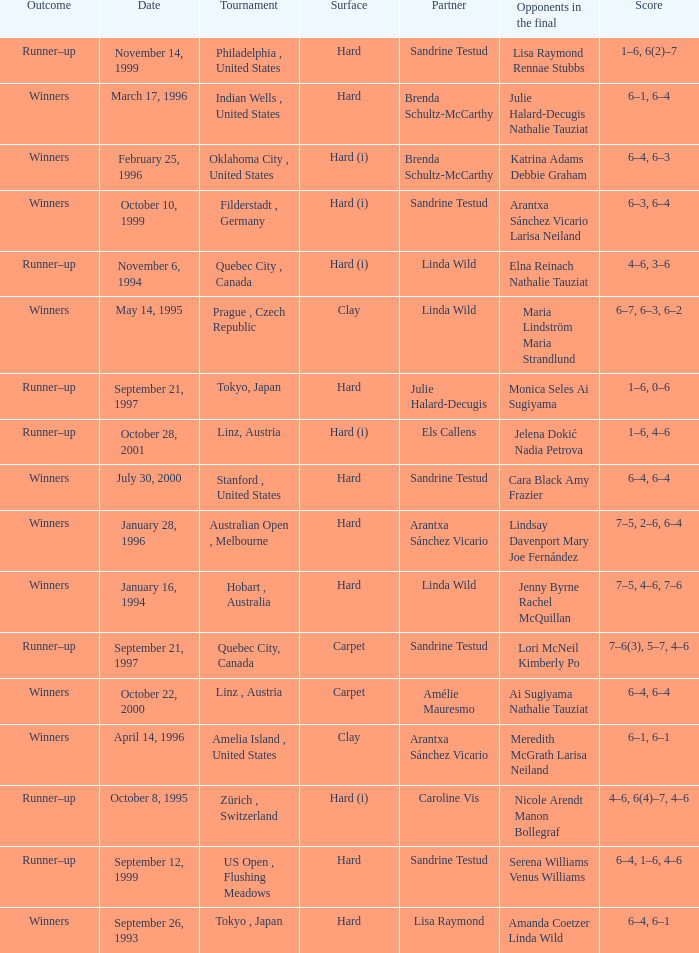Help me parse the entirety of this table. {'header': ['Outcome', 'Date', 'Tournament', 'Surface', 'Partner', 'Opponents in the final', 'Score'], 'rows': [['Runner–up', 'November 14, 1999', 'Philadelphia , United States', 'Hard', 'Sandrine Testud', 'Lisa Raymond Rennae Stubbs', '1–6, 6(2)–7'], ['Winners', 'March 17, 1996', 'Indian Wells , United States', 'Hard', 'Brenda Schultz-McCarthy', 'Julie Halard-Decugis Nathalie Tauziat', '6–1, 6–4'], ['Winners', 'February 25, 1996', 'Oklahoma City , United States', 'Hard (i)', 'Brenda Schultz-McCarthy', 'Katrina Adams Debbie Graham', '6–4, 6–3'], ['Winners', 'October 10, 1999', 'Filderstadt , Germany', 'Hard (i)', 'Sandrine Testud', 'Arantxa Sánchez Vicario Larisa Neiland', '6–3, 6–4'], ['Runner–up', 'November 6, 1994', 'Quebec City , Canada', 'Hard (i)', 'Linda Wild', 'Elna Reinach Nathalie Tauziat', '4–6, 3–6'], ['Winners', 'May 14, 1995', 'Prague , Czech Republic', 'Clay', 'Linda Wild', 'Maria Lindström Maria Strandlund', '6–7, 6–3, 6–2'], ['Runner–up', 'September 21, 1997', 'Tokyo, Japan', 'Hard', 'Julie Halard-Decugis', 'Monica Seles Ai Sugiyama', '1–6, 0–6'], ['Runner–up', 'October 28, 2001', 'Linz, Austria', 'Hard (i)', 'Els Callens', 'Jelena Dokić Nadia Petrova', '1–6, 4–6'], ['Winners', 'July 30, 2000', 'Stanford , United States', 'Hard', 'Sandrine Testud', 'Cara Black Amy Frazier', '6–4, 6–4'], ['Winners', 'January 28, 1996', 'Australian Open , Melbourne', 'Hard', 'Arantxa Sánchez Vicario', 'Lindsay Davenport Mary Joe Fernández', '7–5, 2–6, 6–4'], ['Winners', 'January 16, 1994', 'Hobart , Australia', 'Hard', 'Linda Wild', 'Jenny Byrne Rachel McQuillan', '7–5, 4–6, 7–6'], ['Runner–up', 'September 21, 1997', 'Quebec City, Canada', 'Carpet', 'Sandrine Testud', 'Lori McNeil Kimberly Po', '7–6(3), 5–7, 4–6'], ['Winners', 'October 22, 2000', 'Linz , Austria', 'Carpet', 'Amélie Mauresmo', 'Ai Sugiyama Nathalie Tauziat', '6–4, 6–4'], ['Winners', 'April 14, 1996', 'Amelia Island , United States', 'Clay', 'Arantxa Sánchez Vicario', 'Meredith McGrath Larisa Neiland', '6–1, 6–1'], ['Runner–up', 'October 8, 1995', 'Zürich , Switzerland', 'Hard (i)', 'Caroline Vis', 'Nicole Arendt Manon Bollegraf', '4–6, 6(4)–7, 4–6'], ['Runner–up', 'September 12, 1999', 'US Open , Flushing Meadows', 'Hard', 'Sandrine Testud', 'Serena Williams Venus Williams', '6–4, 1–6, 4–6'], ['Winners', 'September 26, 1993', 'Tokyo , Japan', 'Hard', 'Lisa Raymond', 'Amanda Coetzer Linda Wild', '6–4, 6–1']]} Which surface had a partner of Sandrine Testud on November 14, 1999? Hard. 